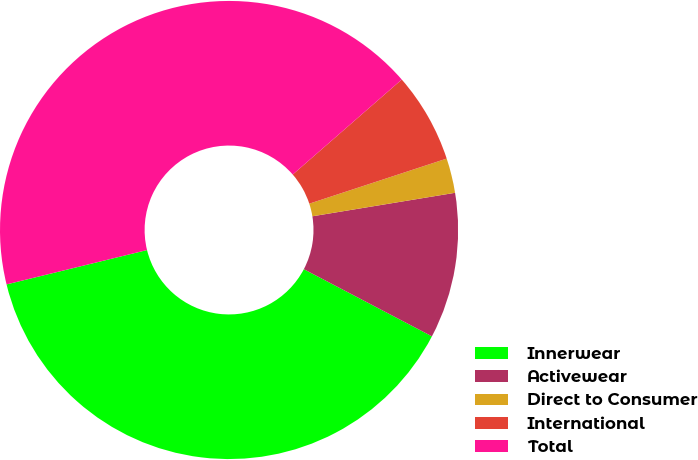Convert chart. <chart><loc_0><loc_0><loc_500><loc_500><pie_chart><fcel>Innerwear<fcel>Activewear<fcel>Direct to Consumer<fcel>International<fcel>Total<nl><fcel>38.5%<fcel>10.28%<fcel>2.45%<fcel>6.36%<fcel>42.41%<nl></chart> 